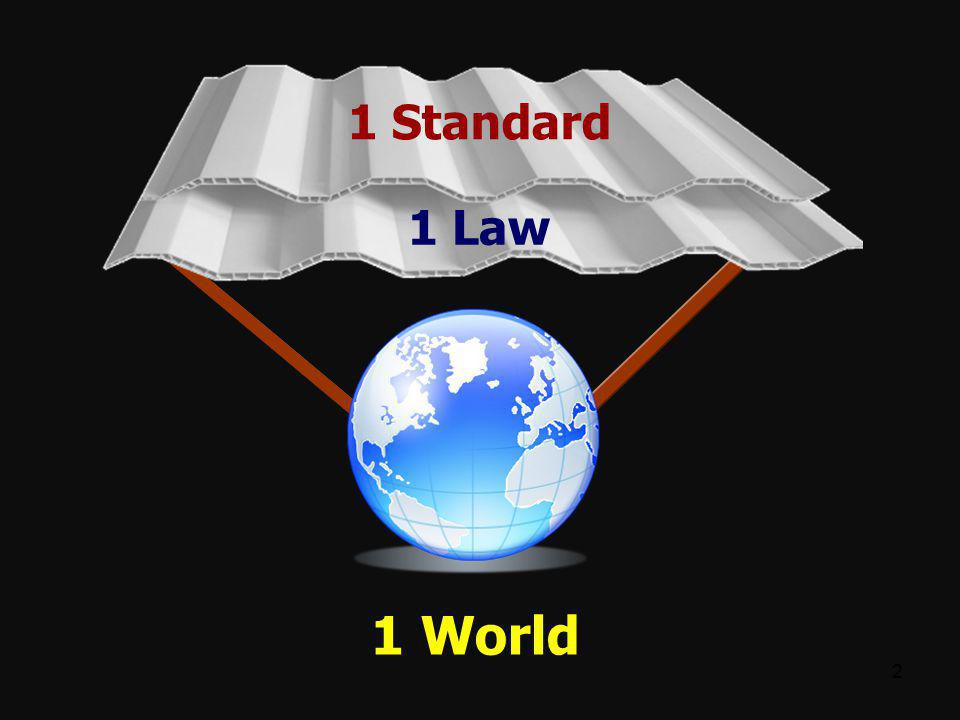Why is global unity being depicted with the phrases '1 Standard', '1 Law', and '1 World'? The image uses the phrases '1 Standard', '1 Law', and '1 World' to illustrate the idea of global unification. The concept suggests that having a single standard and a single set of laws can bring about a unified world, where everyone adheres to the sharegpt4v/same principles, thereby facilitating harmony, equality, and efficient governance on a global scale. 